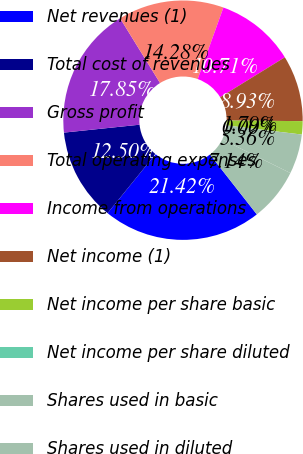Convert chart to OTSL. <chart><loc_0><loc_0><loc_500><loc_500><pie_chart><fcel>Net revenues (1)<fcel>Total cost of revenues<fcel>Gross profit<fcel>Total operating expenses<fcel>Income from operations<fcel>Net income (1)<fcel>Net income per share basic<fcel>Net income per share diluted<fcel>Shares used in basic<fcel>Shares used in diluted<nl><fcel>21.42%<fcel>12.5%<fcel>17.85%<fcel>14.28%<fcel>10.71%<fcel>8.93%<fcel>1.79%<fcel>0.0%<fcel>5.36%<fcel>7.14%<nl></chart> 